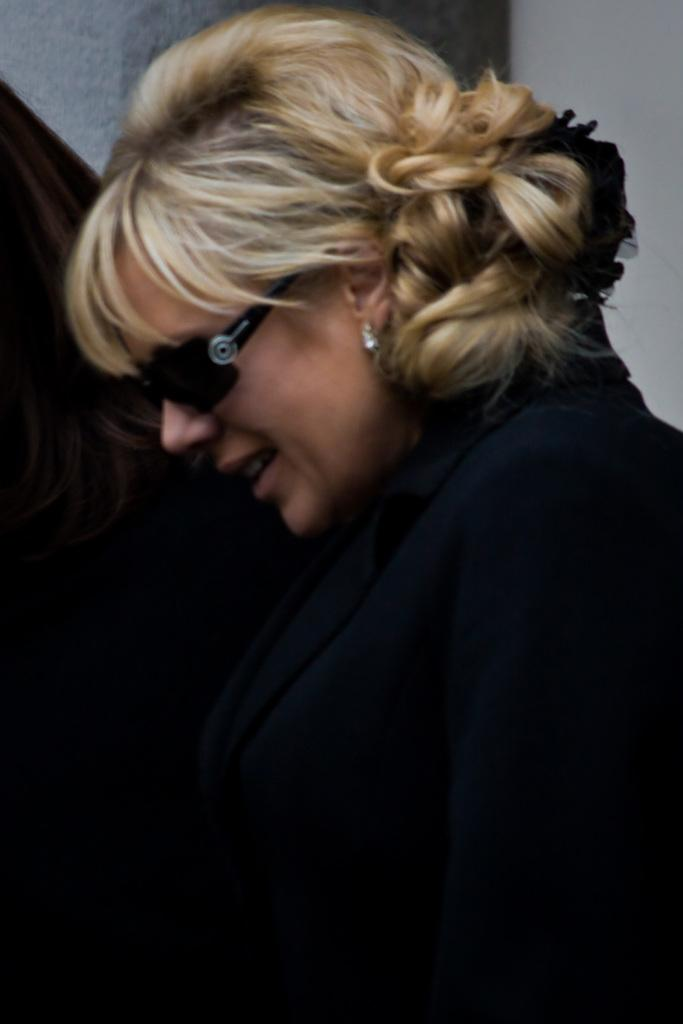Who is present in the image? There is a woman in the image. What is the woman wearing on her eyes? The woman is wearing goggles on her eyes. What can be seen in the background of the image? There is a wall and a person in the background of the image. What type of chess piece is the woman holding in the image? There is no chess piece present in the image. What type of collar is the woman wearing in the image? The woman is not wearing a collar in the image; she is wearing goggles on her eyes. 